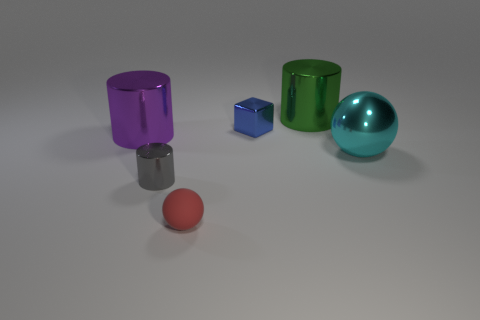There is another object that is the same shape as the big cyan metal object; what material is it?
Provide a short and direct response. Rubber. Is the number of tiny red rubber things greater than the number of large brown matte cylinders?
Ensure brevity in your answer.  Yes. Does the blue block have the same size as the cylinder that is on the left side of the small metal cylinder?
Provide a succinct answer. No. The small object in front of the small gray cylinder is what color?
Ensure brevity in your answer.  Red. What number of purple things are either large shiny spheres or tiny shiny things?
Ensure brevity in your answer.  0. The small cylinder is what color?
Make the answer very short. Gray. Are there any other things that are made of the same material as the tiny red ball?
Offer a very short reply. No. Are there fewer metallic cylinders behind the large green object than tiny objects behind the large shiny ball?
Make the answer very short. Yes. There is a thing that is left of the matte ball and behind the gray cylinder; what is its shape?
Offer a terse response. Cylinder. What number of large objects are the same shape as the small gray object?
Your answer should be very brief. 2. 